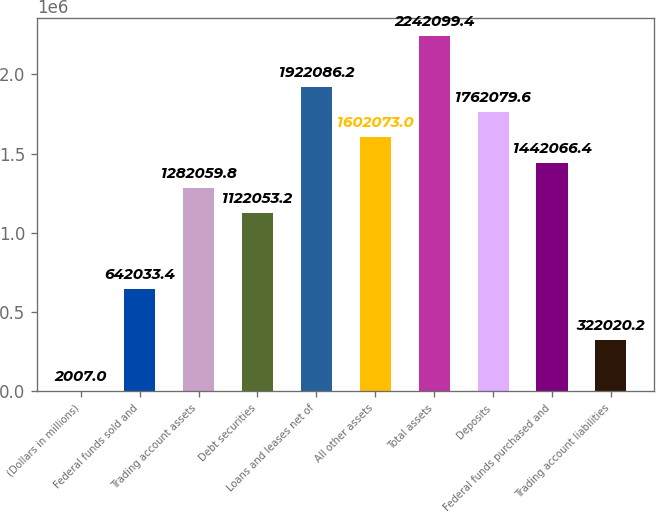Convert chart to OTSL. <chart><loc_0><loc_0><loc_500><loc_500><bar_chart><fcel>(Dollars in millions)<fcel>Federal funds sold and<fcel>Trading account assets<fcel>Debt securities<fcel>Loans and leases net of<fcel>All other assets<fcel>Total assets<fcel>Deposits<fcel>Federal funds purchased and<fcel>Trading account liabilities<nl><fcel>2007<fcel>642033<fcel>1.28206e+06<fcel>1.12205e+06<fcel>1.92209e+06<fcel>1.60207e+06<fcel>2.2421e+06<fcel>1.76208e+06<fcel>1.44207e+06<fcel>322020<nl></chart> 